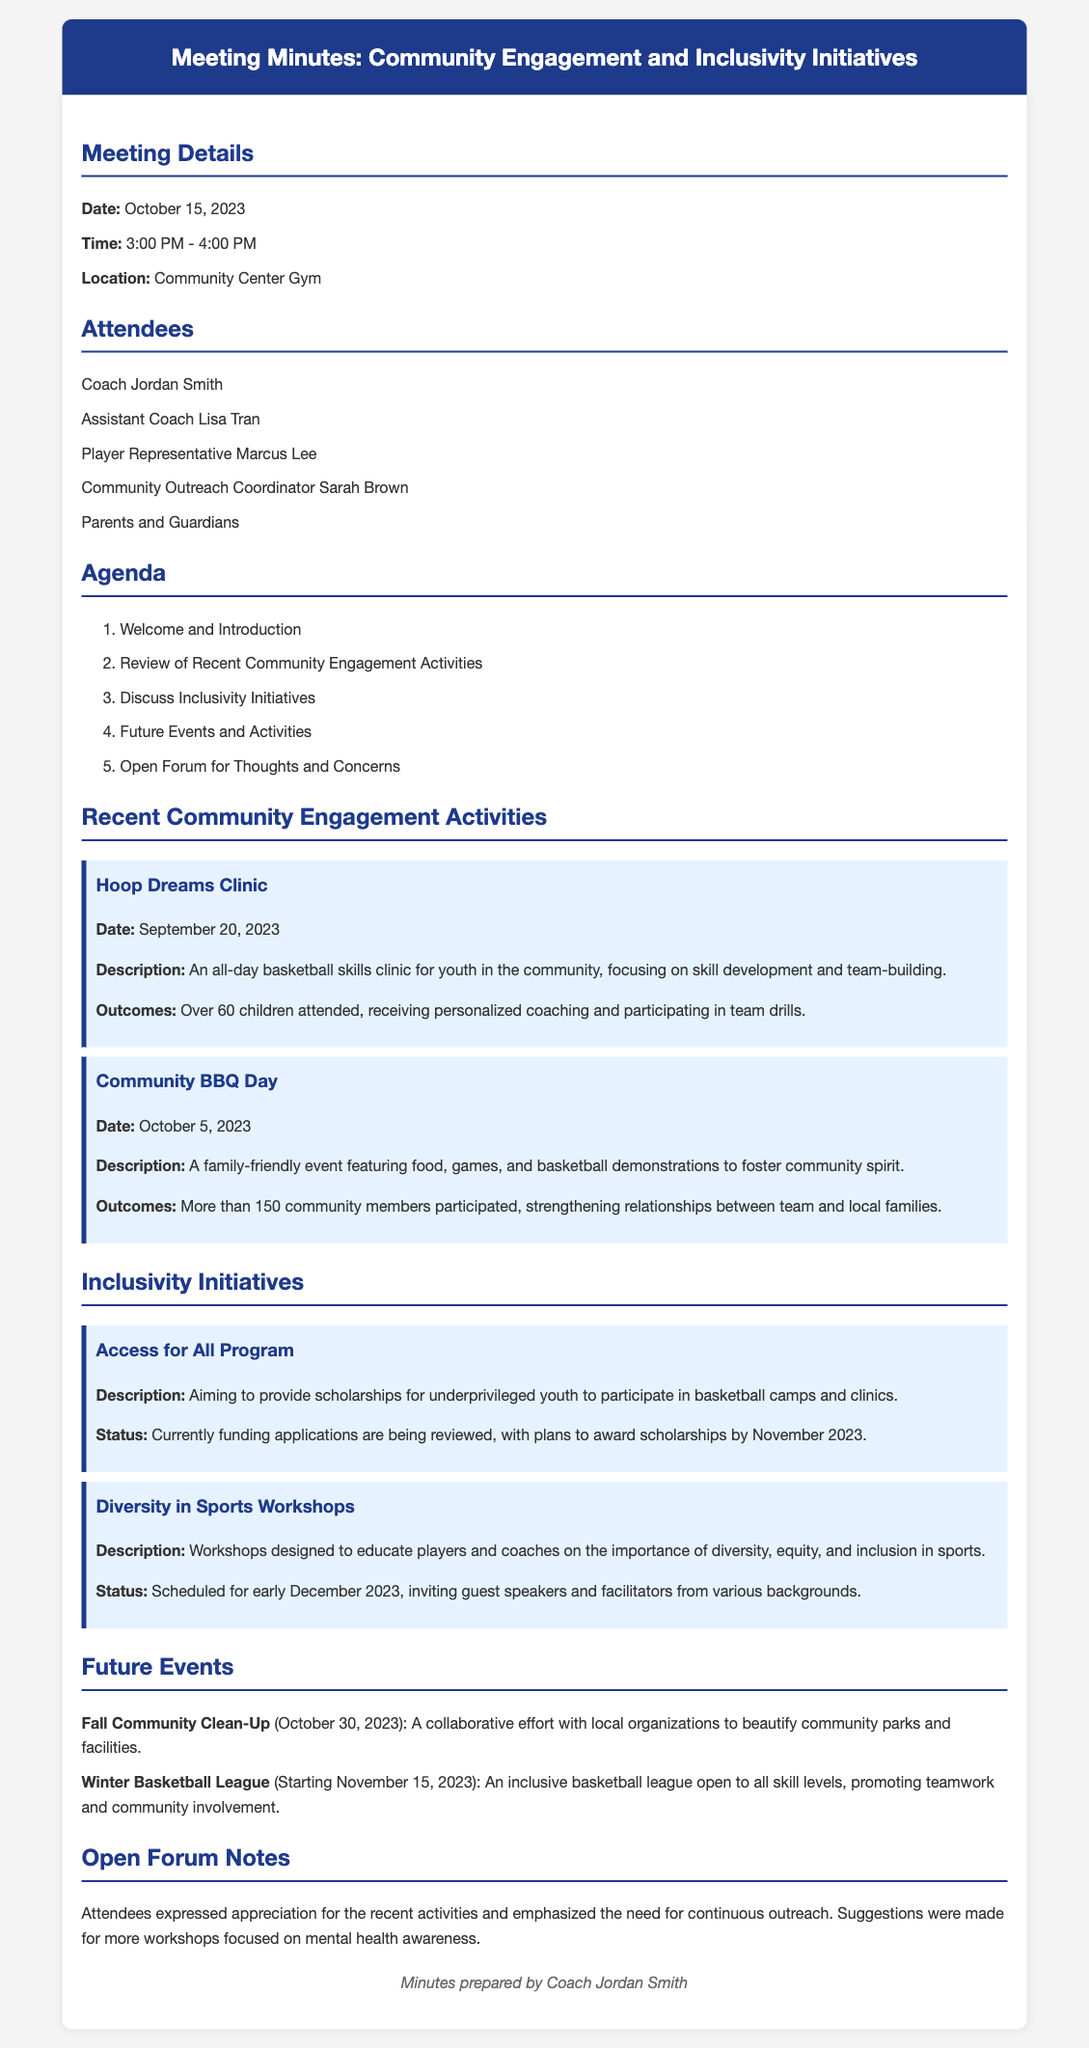What is the date of the meeting? The date of the meeting is clearly stated in the document, which is October 15, 2023.
Answer: October 15, 2023 How many children attended the Hoop Dreams Clinic? The document mentions that over 60 children attended the Hoop Dreams Clinic.
Answer: Over 60 What is the purpose of the Access for All Program? The document describes the Access for All Program as aiming to provide scholarships for underprivileged youth.
Answer: Scholarships for underprivileged youth When is the Winter Basketball League starting? The document states that the Winter Basketball League is starting on November 15, 2023.
Answer: November 15, 2023 What was the outcome of the Community BBQ Day? The document specifies that more than 150 community members participated, strengthening relationships between team and local families.
Answer: More than 150 community members participated What do participants appreciate regarding community engagement? Attendees expressed appreciation for the recent activities in the Open Forum Notes.
Answer: Recent activities What event is scheduled for October 30, 2023? According to the document, the Fall Community Clean-Up is scheduled for October 30, 2023.
Answer: Fall Community Clean-Up Who prepared the minutes? The footer in the document indicates that Coach Jordan Smith prepared the minutes.
Answer: Coach Jordan Smith 